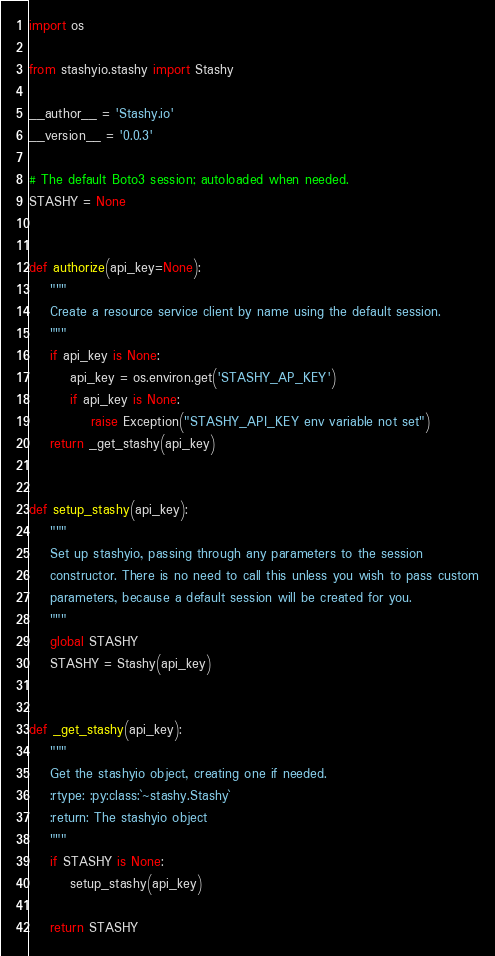Convert code to text. <code><loc_0><loc_0><loc_500><loc_500><_Python_>import os

from stashyio.stashy import Stashy

__author__ = 'Stashy.io'
__version__ = '0.0.3'

# The default Boto3 session; autoloaded when needed.
STASHY = None


def authorize(api_key=None):
    """
    Create a resource service client by name using the default session.
    """
    if api_key is None:
        api_key = os.environ.get('STASHY_AP_KEY')
        if api_key is None:
            raise Exception("STASHY_API_KEY env variable not set")
    return _get_stashy(api_key)


def setup_stashy(api_key):
    """
    Set up stashyio, passing through any parameters to the session
    constructor. There is no need to call this unless you wish to pass custom
    parameters, because a default session will be created for you.
    """
    global STASHY
    STASHY = Stashy(api_key)


def _get_stashy(api_key):
    """
    Get the stashyio object, creating one if needed.
    :rtype: :py:class:`~stashy.Stashy`
    :return: The stashyio object
    """
    if STASHY is None:
        setup_stashy(api_key)

    return STASHY
</code> 